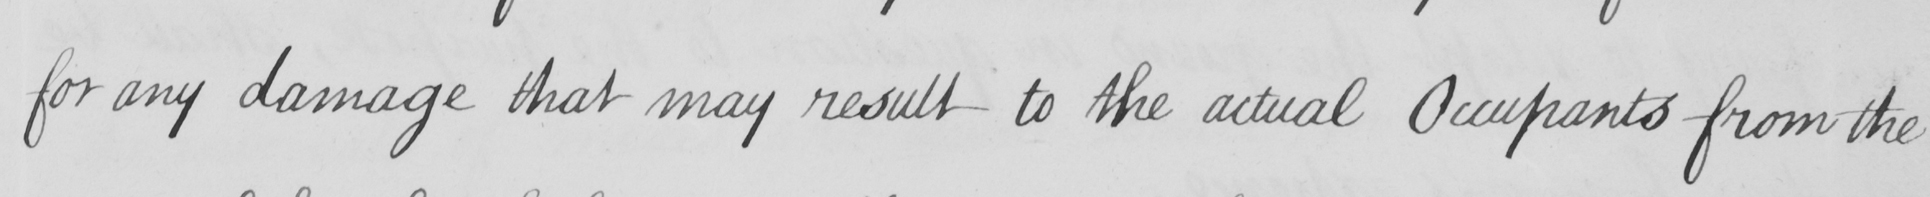What does this handwritten line say? for any damage that may result to the actual Occupants from the 